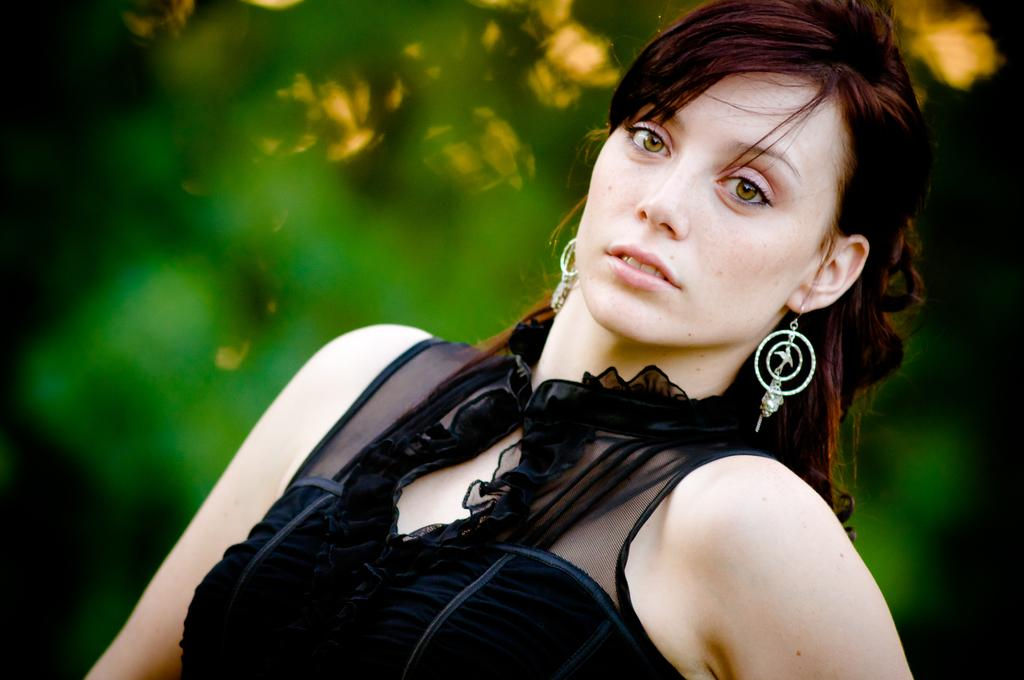Who is the main subject in the image? There is a woman in the image. Where is the woman located in the image? The woman is towards the bottom of the image. What can be said about the background of the image? The background of the image is blurred and green in color. What example of a fire can be seen in the image? There is no example of a fire present in the image. What theory is being demonstrated in the image? There is no theory being demonstrated in the image; it simply features a woman in a green, blurred background. 